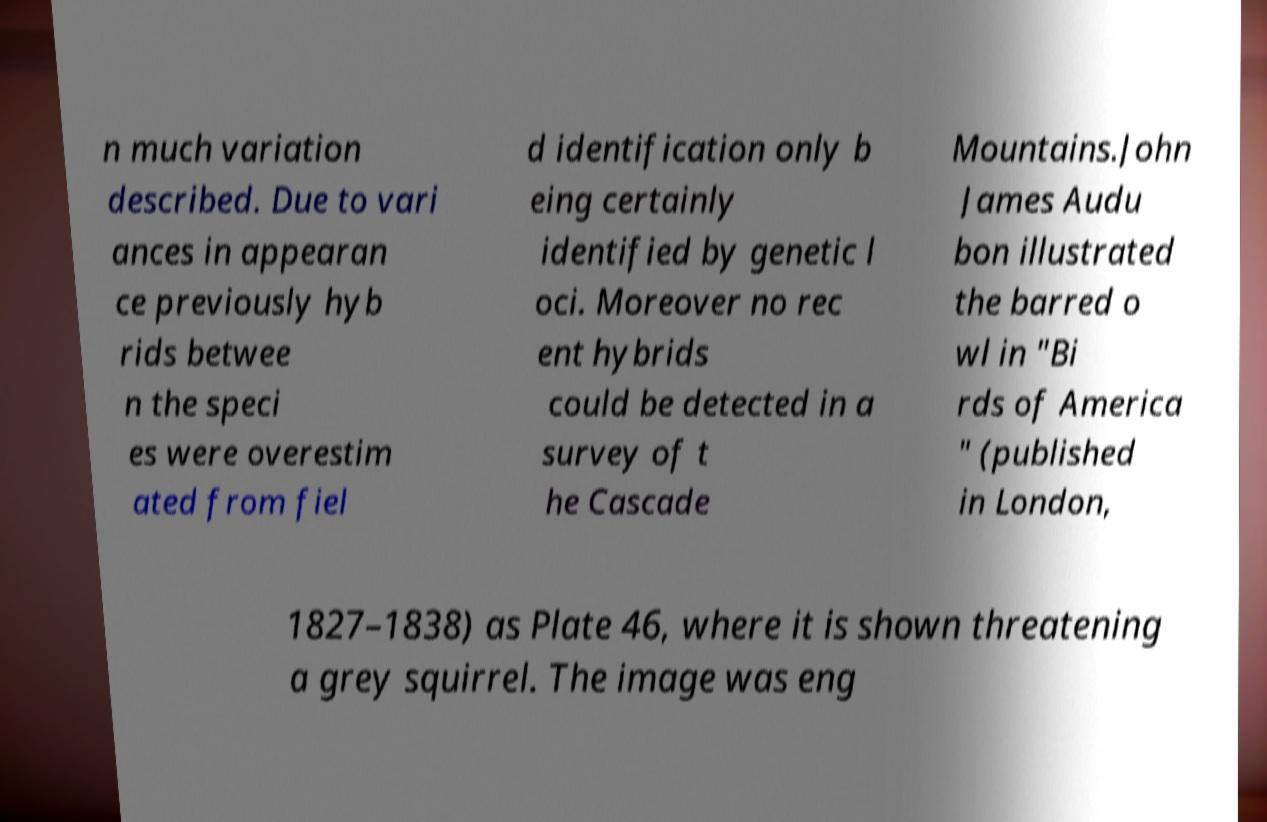Please identify and transcribe the text found in this image. n much variation described. Due to vari ances in appearan ce previously hyb rids betwee n the speci es were overestim ated from fiel d identification only b eing certainly identified by genetic l oci. Moreover no rec ent hybrids could be detected in a survey of t he Cascade Mountains.John James Audu bon illustrated the barred o wl in "Bi rds of America " (published in London, 1827–1838) as Plate 46, where it is shown threatening a grey squirrel. The image was eng 